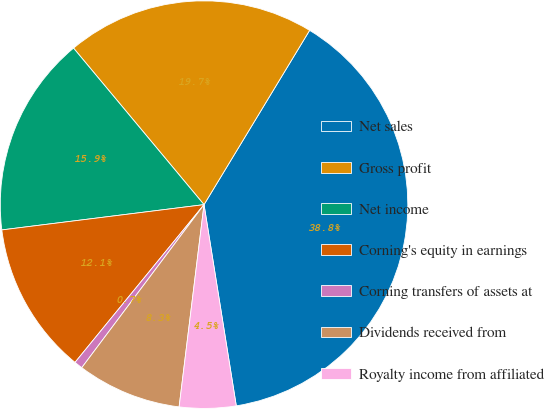Convert chart. <chart><loc_0><loc_0><loc_500><loc_500><pie_chart><fcel>Net sales<fcel>Gross profit<fcel>Net income<fcel>Corning's equity in earnings<fcel>Corning transfers of assets at<fcel>Dividends received from<fcel>Royalty income from affiliated<nl><fcel>38.8%<fcel>19.73%<fcel>15.92%<fcel>12.11%<fcel>0.67%<fcel>8.29%<fcel>4.48%<nl></chart> 